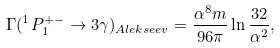Convert formula to latex. <formula><loc_0><loc_0><loc_500><loc_500>\Gamma ( ^ { 1 } P _ { 1 } ^ { + - } \rightarrow 3 \gamma ) _ { A l e k s e e v } = \frac { \alpha ^ { 8 } m } { 9 6 \pi } \ln \frac { 3 2 } { \alpha ^ { 2 } } ,</formula> 